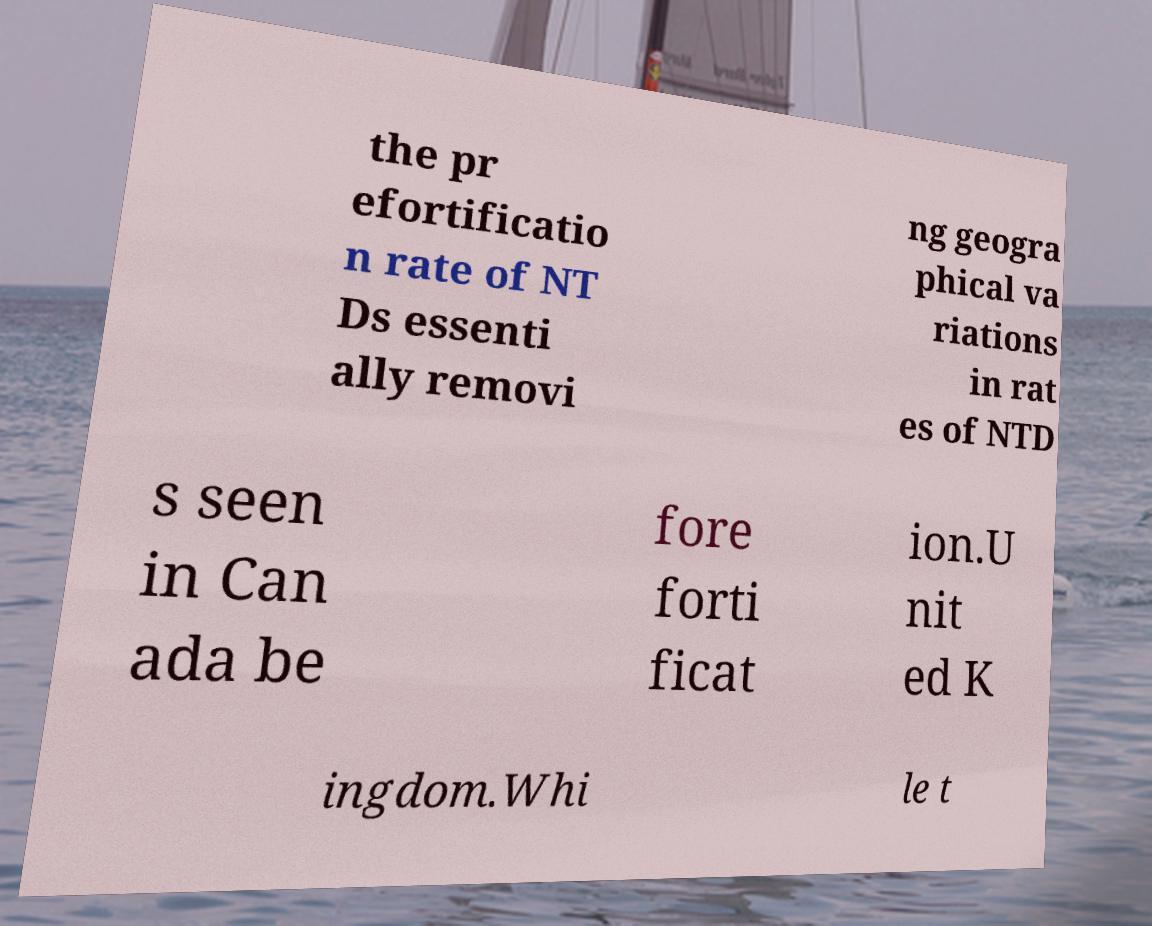For documentation purposes, I need the text within this image transcribed. Could you provide that? the pr efortificatio n rate of NT Ds essenti ally removi ng geogra phical va riations in rat es of NTD s seen in Can ada be fore forti ficat ion.U nit ed K ingdom.Whi le t 